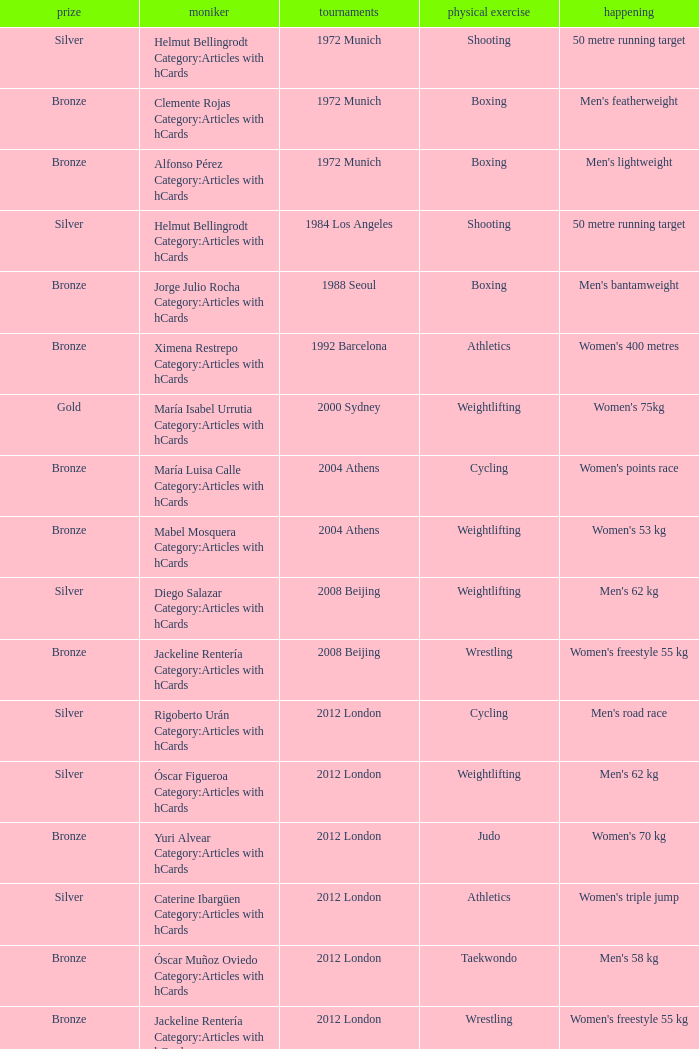Which wrestling event was at the 2008 Beijing games? Women's freestyle 55 kg. 